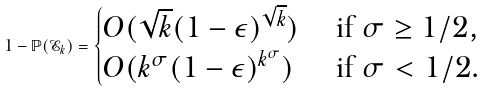Convert formula to latex. <formula><loc_0><loc_0><loc_500><loc_500>1 - \mathbb { P } ( \mathcal { E } _ { k } ) = \begin{cases} O ( \sqrt { k } ( 1 - \epsilon ) ^ { \sqrt { k } } ) & \text { if } \sigma \geq 1 / 2 , \\ O ( k ^ { \sigma } ( 1 - \epsilon ) ^ { k ^ { \sigma } } ) & \text { if } \sigma < 1 / 2 . \end{cases}</formula> 